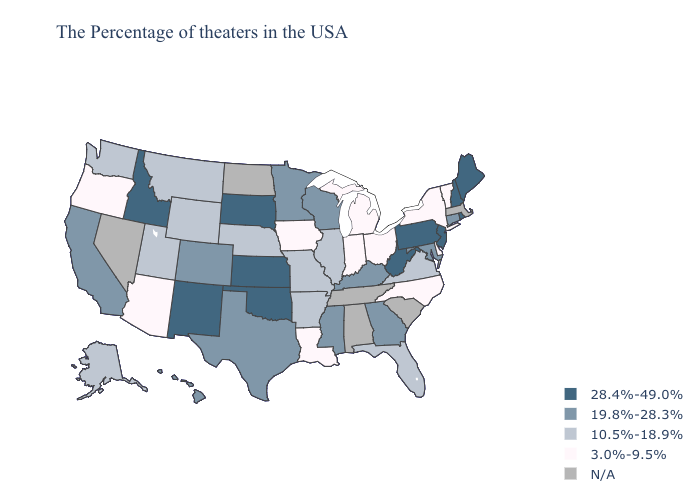What is the lowest value in the South?
Write a very short answer. 3.0%-9.5%. Which states have the highest value in the USA?
Keep it brief. Maine, Rhode Island, New Hampshire, New Jersey, Pennsylvania, West Virginia, Kansas, Oklahoma, South Dakota, New Mexico, Idaho. What is the lowest value in the Northeast?
Quick response, please. 3.0%-9.5%. Which states have the highest value in the USA?
Short answer required. Maine, Rhode Island, New Hampshire, New Jersey, Pennsylvania, West Virginia, Kansas, Oklahoma, South Dakota, New Mexico, Idaho. Which states have the lowest value in the USA?
Give a very brief answer. Vermont, New York, Delaware, North Carolina, Ohio, Michigan, Indiana, Louisiana, Iowa, Arizona, Oregon. Among the states that border South Carolina , does Georgia have the lowest value?
Quick response, please. No. Is the legend a continuous bar?
Concise answer only. No. Among the states that border Virginia , does Maryland have the lowest value?
Be succinct. No. Among the states that border Colorado , does New Mexico have the lowest value?
Answer briefly. No. Which states have the highest value in the USA?
Short answer required. Maine, Rhode Island, New Hampshire, New Jersey, Pennsylvania, West Virginia, Kansas, Oklahoma, South Dakota, New Mexico, Idaho. What is the lowest value in states that border North Dakota?
Give a very brief answer. 10.5%-18.9%. Does the map have missing data?
Give a very brief answer. Yes. Name the states that have a value in the range 28.4%-49.0%?
Short answer required. Maine, Rhode Island, New Hampshire, New Jersey, Pennsylvania, West Virginia, Kansas, Oklahoma, South Dakota, New Mexico, Idaho. What is the lowest value in states that border Nevada?
Be succinct. 3.0%-9.5%. 